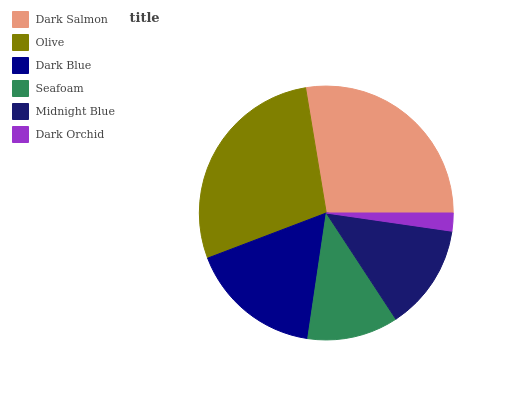Is Dark Orchid the minimum?
Answer yes or no. Yes. Is Olive the maximum?
Answer yes or no. Yes. Is Dark Blue the minimum?
Answer yes or no. No. Is Dark Blue the maximum?
Answer yes or no. No. Is Olive greater than Dark Blue?
Answer yes or no. Yes. Is Dark Blue less than Olive?
Answer yes or no. Yes. Is Dark Blue greater than Olive?
Answer yes or no. No. Is Olive less than Dark Blue?
Answer yes or no. No. Is Dark Blue the high median?
Answer yes or no. Yes. Is Midnight Blue the low median?
Answer yes or no. Yes. Is Midnight Blue the high median?
Answer yes or no. No. Is Dark Blue the low median?
Answer yes or no. No. 